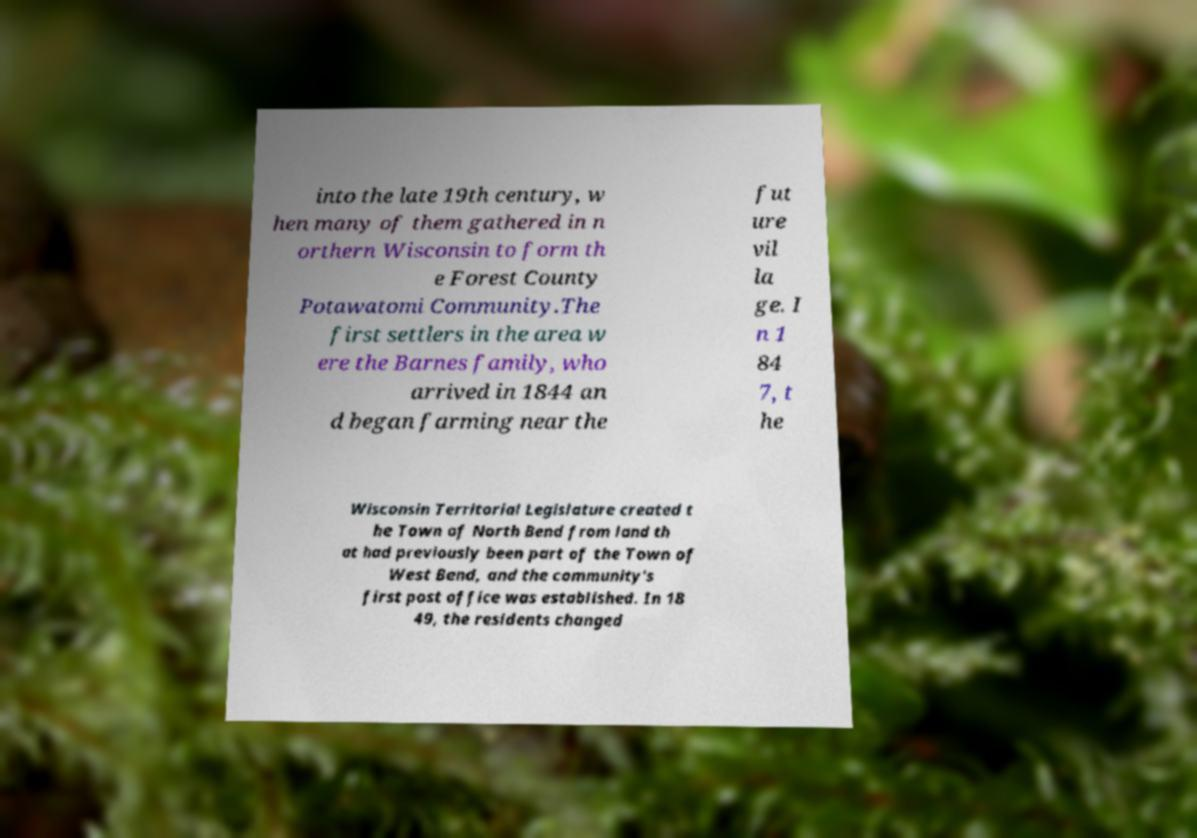Can you accurately transcribe the text from the provided image for me? into the late 19th century, w hen many of them gathered in n orthern Wisconsin to form th e Forest County Potawatomi Community.The first settlers in the area w ere the Barnes family, who arrived in 1844 an d began farming near the fut ure vil la ge. I n 1 84 7, t he Wisconsin Territorial Legislature created t he Town of North Bend from land th at had previously been part of the Town of West Bend, and the community's first post office was established. In 18 49, the residents changed 